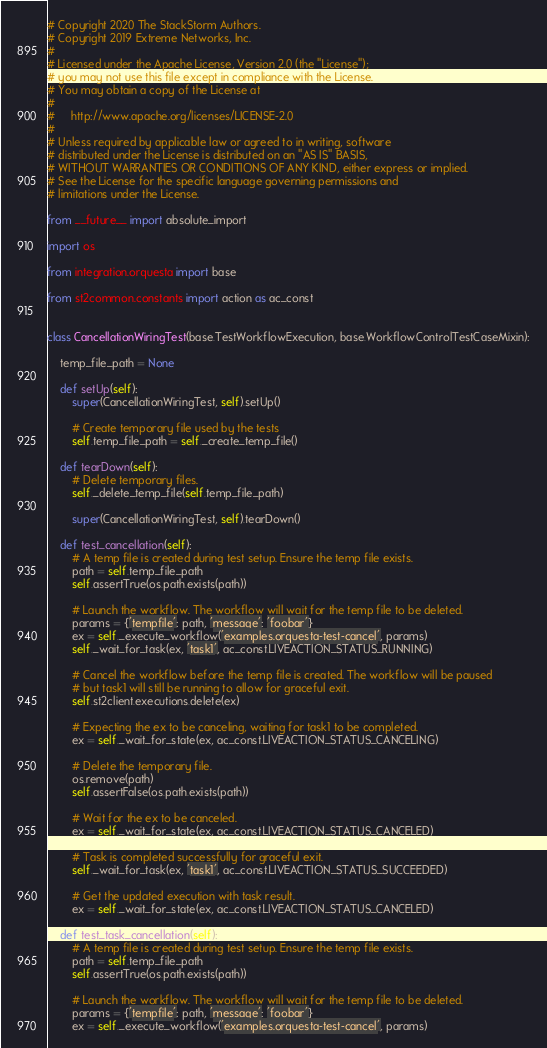<code> <loc_0><loc_0><loc_500><loc_500><_Python_># Copyright 2020 The StackStorm Authors.
# Copyright 2019 Extreme Networks, Inc.
#
# Licensed under the Apache License, Version 2.0 (the "License");
# you may not use this file except in compliance with the License.
# You may obtain a copy of the License at
#
#     http://www.apache.org/licenses/LICENSE-2.0
#
# Unless required by applicable law or agreed to in writing, software
# distributed under the License is distributed on an "AS IS" BASIS,
# WITHOUT WARRANTIES OR CONDITIONS OF ANY KIND, either express or implied.
# See the License for the specific language governing permissions and
# limitations under the License.

from __future__ import absolute_import

import os

from integration.orquesta import base

from st2common.constants import action as ac_const


class CancellationWiringTest(base.TestWorkflowExecution, base.WorkflowControlTestCaseMixin):

    temp_file_path = None

    def setUp(self):
        super(CancellationWiringTest, self).setUp()

        # Create temporary file used by the tests
        self.temp_file_path = self._create_temp_file()

    def tearDown(self):
        # Delete temporary files.
        self._delete_temp_file(self.temp_file_path)

        super(CancellationWiringTest, self).tearDown()

    def test_cancellation(self):
        # A temp file is created during test setup. Ensure the temp file exists.
        path = self.temp_file_path
        self.assertTrue(os.path.exists(path))

        # Launch the workflow. The workflow will wait for the temp file to be deleted.
        params = {'tempfile': path, 'message': 'foobar'}
        ex = self._execute_workflow('examples.orquesta-test-cancel', params)
        self._wait_for_task(ex, 'task1', ac_const.LIVEACTION_STATUS_RUNNING)

        # Cancel the workflow before the temp file is created. The workflow will be paused
        # but task1 will still be running to allow for graceful exit.
        self.st2client.executions.delete(ex)

        # Expecting the ex to be canceling, waiting for task1 to be completed.
        ex = self._wait_for_state(ex, ac_const.LIVEACTION_STATUS_CANCELING)

        # Delete the temporary file.
        os.remove(path)
        self.assertFalse(os.path.exists(path))

        # Wait for the ex to be canceled.
        ex = self._wait_for_state(ex, ac_const.LIVEACTION_STATUS_CANCELED)

        # Task is completed successfully for graceful exit.
        self._wait_for_task(ex, 'task1', ac_const.LIVEACTION_STATUS_SUCCEEDED)

        # Get the updated execution with task result.
        ex = self._wait_for_state(ex, ac_const.LIVEACTION_STATUS_CANCELED)

    def test_task_cancellation(self):
        # A temp file is created during test setup. Ensure the temp file exists.
        path = self.temp_file_path
        self.assertTrue(os.path.exists(path))

        # Launch the workflow. The workflow will wait for the temp file to be deleted.
        params = {'tempfile': path, 'message': 'foobar'}
        ex = self._execute_workflow('examples.orquesta-test-cancel', params)</code> 